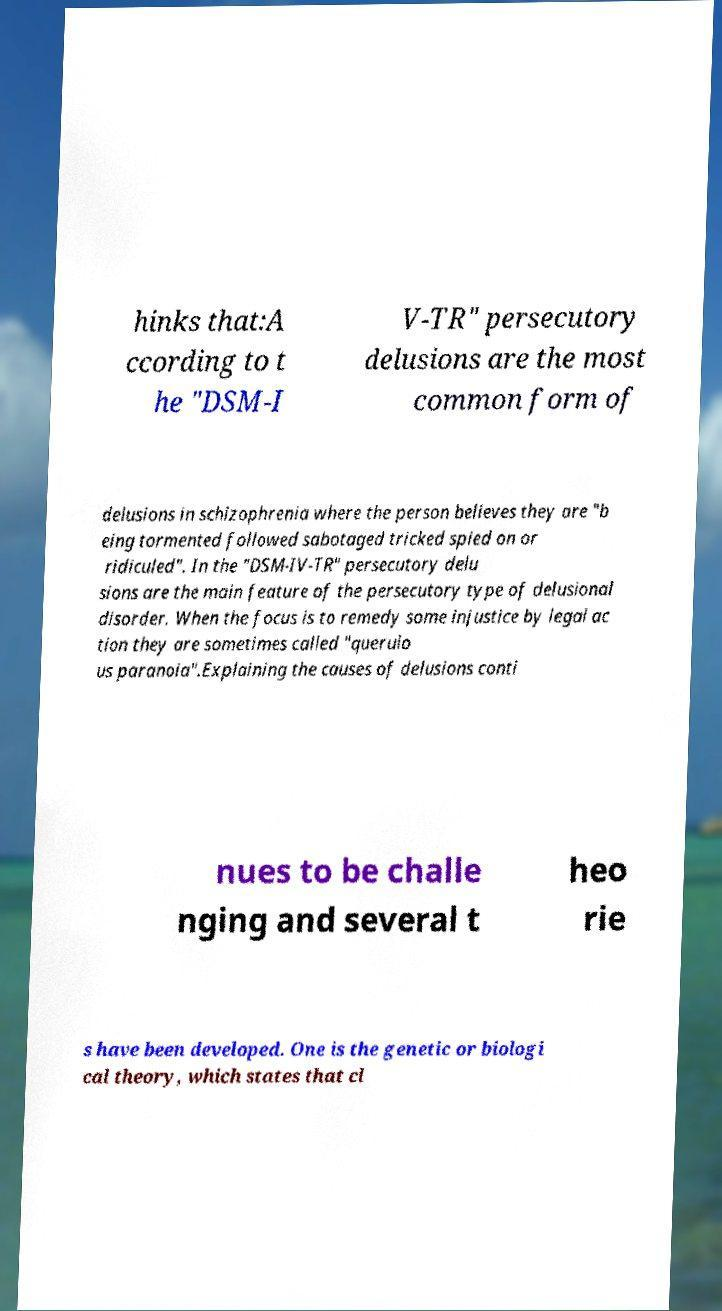Could you assist in decoding the text presented in this image and type it out clearly? hinks that:A ccording to t he "DSM-I V-TR" persecutory delusions are the most common form of delusions in schizophrenia where the person believes they are "b eing tormented followed sabotaged tricked spied on or ridiculed". In the "DSM-IV-TR" persecutory delu sions are the main feature of the persecutory type of delusional disorder. When the focus is to remedy some injustice by legal ac tion they are sometimes called "querulo us paranoia".Explaining the causes of delusions conti nues to be challe nging and several t heo rie s have been developed. One is the genetic or biologi cal theory, which states that cl 